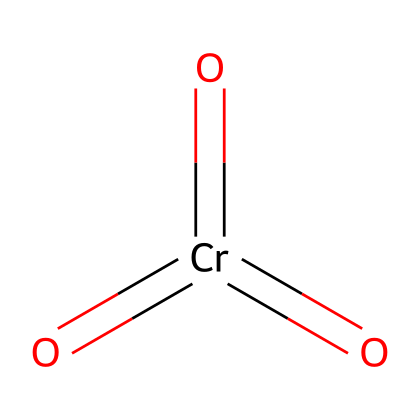What is the chemical name represented by this structure? The provided SMILES corresponds to a chemical formula with the chromium atom at its center, surrounded by three oxygen atoms, indicating that the substance is chromium trioxide.
Answer: chromium trioxide How many oxygen atoms are present in this chemical? The structure shows three oxygen atoms bonded to a single chromium atom, as indicated in the SMILES notation.
Answer: three What type of bond is indicated between chromium and oxygen? The SMILES representation includes equal signs between chromium and oxygen, indicating double bonds between them.
Answer: double bonds What is the oxidation state of chromium in this compound? Analyzing the SMILES structure and considering the usual oxidation states of oxygen (-2), the chromium must be in the +6 oxidation state to balance the overall charge.
Answer: +6 Is chromium trioxide an oxidizer or a reducer? Given the chemical structure, chromium trioxide has the characteristics of an oxidizer, as it readily accepts electrons during chemical reactions.
Answer: oxidizer How does the structure of chromium trioxide contribute to its properties as an oxidizer? The presence of multiple double bonds between chromium and oxygen creates a high electronegativity situation, which means it can easily attract electrons from other substances, enhancing its oxidizing capabilities.
Answer: multiple double bonds What type of molecular geometry does chromium trioxide exhibit? The arrangement of three oxygen atoms around a central chromium, along with the presence of double bonds, suggests that the molecule exhibits a trigonal planar geometry.
Answer: trigonal planar 